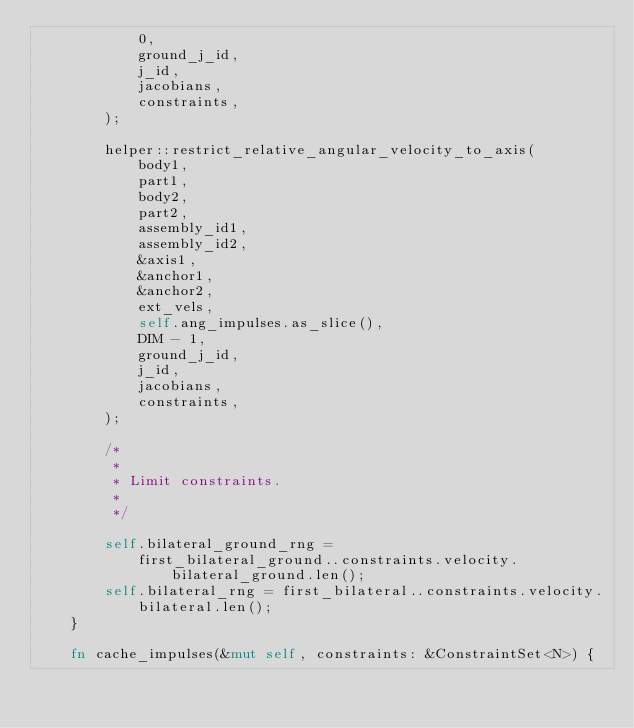<code> <loc_0><loc_0><loc_500><loc_500><_Rust_>            0,
            ground_j_id,
            j_id,
            jacobians,
            constraints,
        );

        helper::restrict_relative_angular_velocity_to_axis(
            body1,
            part1,
            body2,
            part2,
            assembly_id1,
            assembly_id2,
            &axis1,
            &anchor1,
            &anchor2,
            ext_vels,
            self.ang_impulses.as_slice(),
            DIM - 1,
            ground_j_id,
            j_id,
            jacobians,
            constraints,
        );

        /*
         *
         * Limit constraints.
         *
         */

        self.bilateral_ground_rng =
            first_bilateral_ground..constraints.velocity.bilateral_ground.len();
        self.bilateral_rng = first_bilateral..constraints.velocity.bilateral.len();
    }

    fn cache_impulses(&mut self, constraints: &ConstraintSet<N>) {</code> 